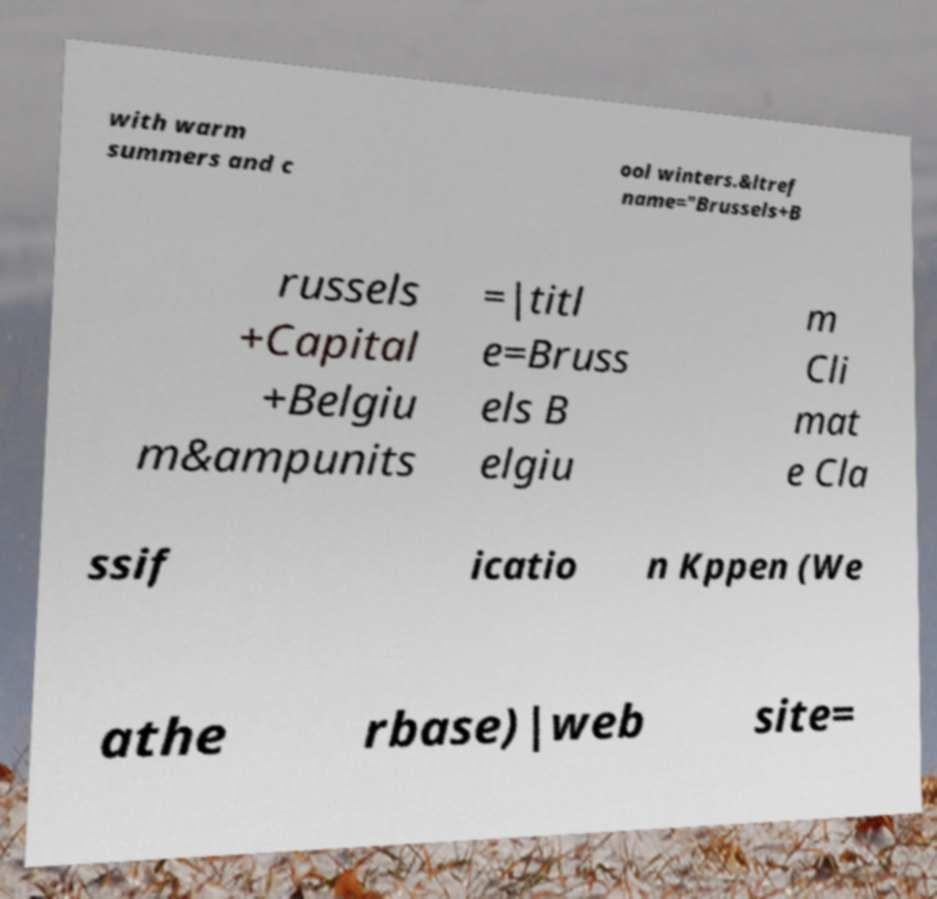Could you extract and type out the text from this image? with warm summers and c ool winters.&ltref name="Brussels+B russels +Capital +Belgiu m&ampunits =|titl e=Bruss els B elgiu m Cli mat e Cla ssif icatio n Kppen (We athe rbase)|web site= 